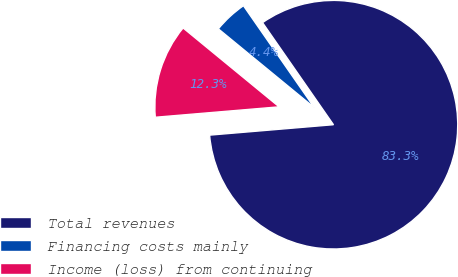<chart> <loc_0><loc_0><loc_500><loc_500><pie_chart><fcel>Total revenues<fcel>Financing costs mainly<fcel>Income (loss) from continuing<nl><fcel>83.32%<fcel>4.39%<fcel>12.28%<nl></chart> 